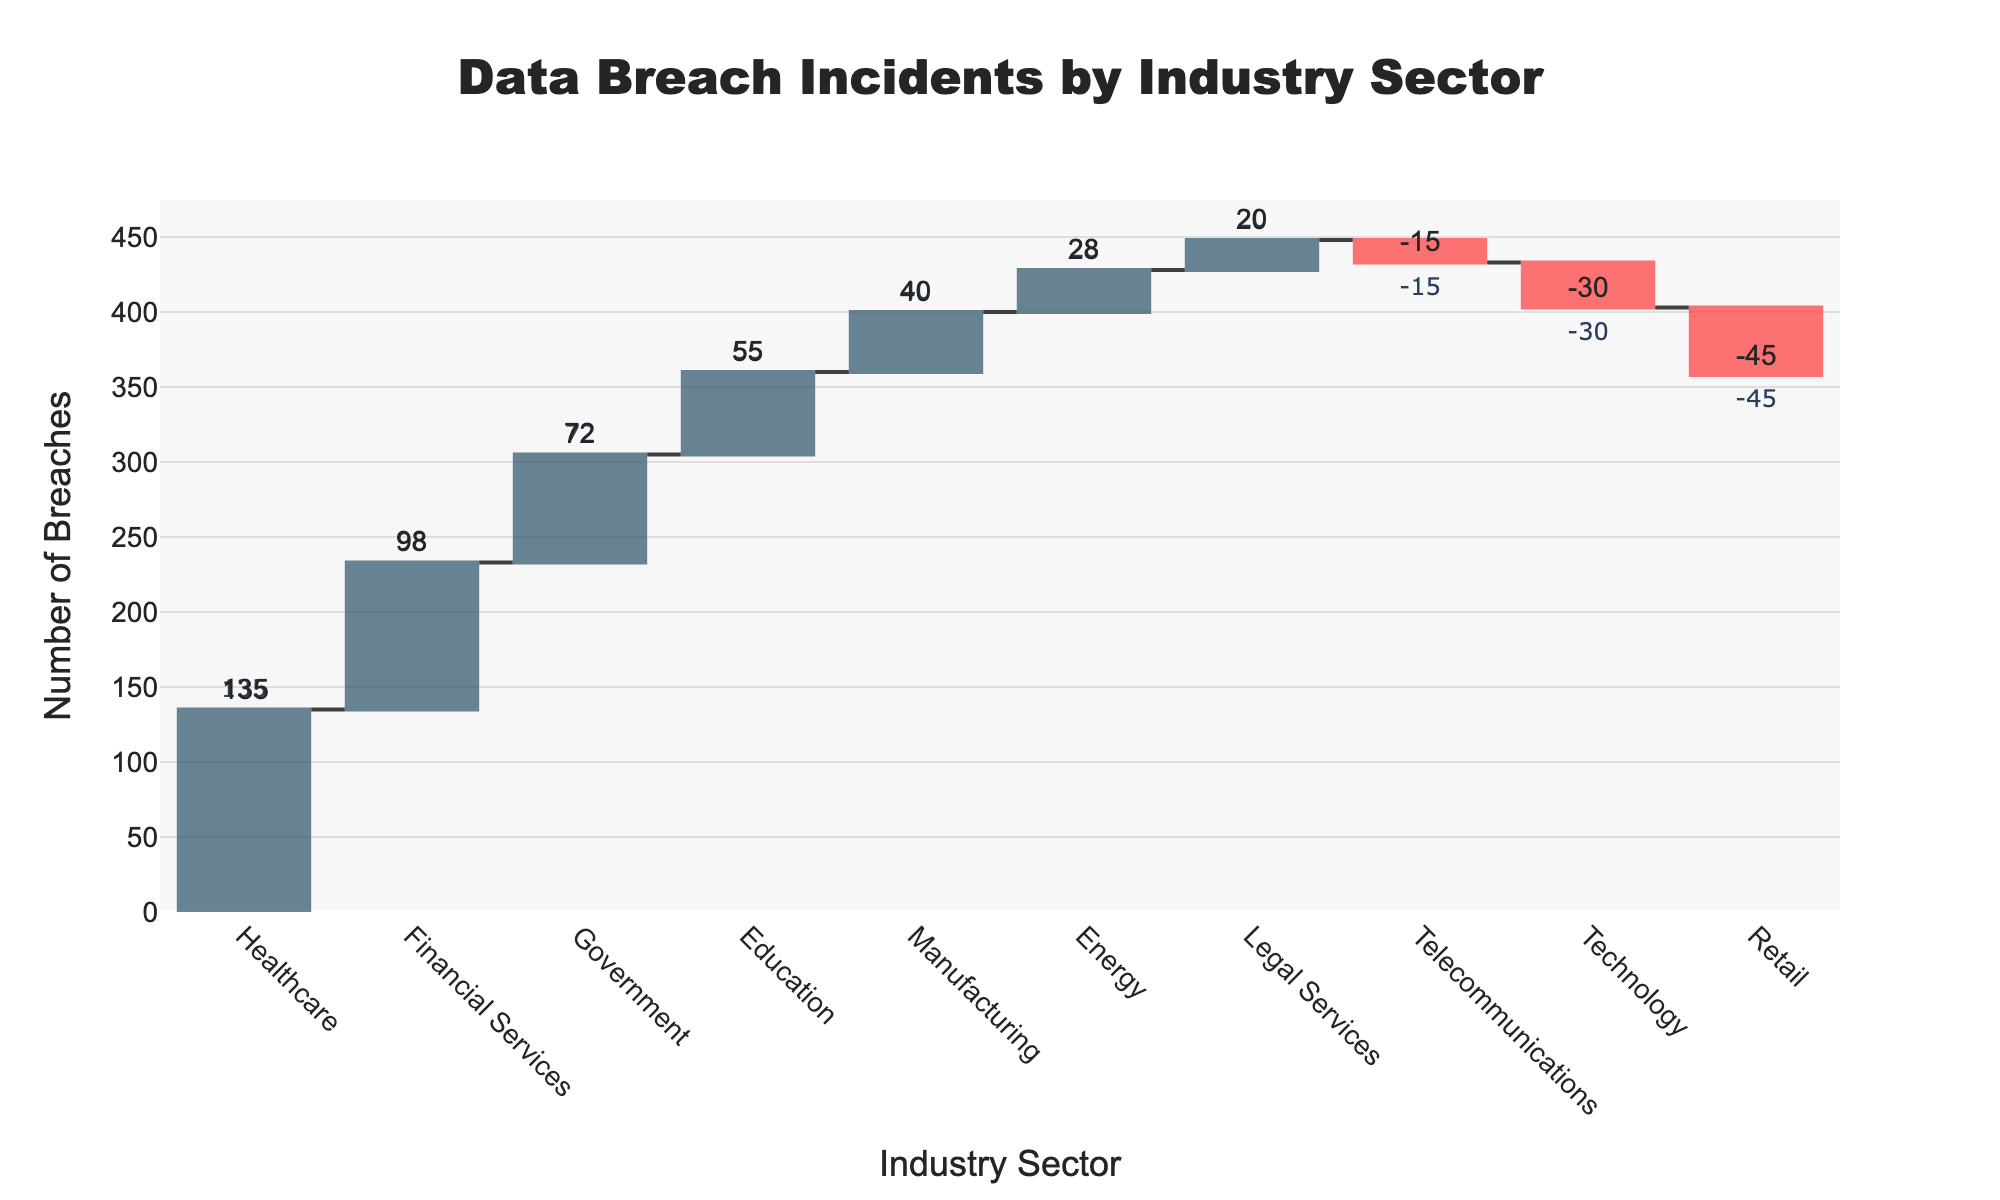What is the title of the plot? The title of the plot is displayed at the top of the figure and typically provides context to the graph. In this case, it reads "Data Breach Incidents by Industry Sector".
Answer: Data Breach Incidents by Industry Sector How many industry sectors experienced data breaches according to the chart? The x-axis of the plot lists the industry sectors. Counting these sectors gives the number of them. In this plot, there are 10 sectors displayed.
Answer: 10 Which industry sector had the highest number of breaches? Look for the tallest bar in the plot, where the bar is in positive direction. The Healthcare sector has the highest bar, indicating the most breaches.
Answer: Healthcare How many breaches did the Retail sector have? The Retail sector's bar is in the negative direction, and the text label outside the bar shows -45 breaches.
Answer: -45 What is the total number of breaches for the sectors with negative breaches combined? Identify the bars that are in the negative direction and sum their values: Retail (-45), Technology (-30), and Telecommunications (-15). Adding these gives -45 + (-30) + (-15) = -90.
Answer: -90 How does the number of breaches in Financial Services compare to that in Government? Compare the heights of the bars for Financial Services and Government. Financial Services has 98 breaches, while Government has 72 breaches. Therefore, Financial Services has more breaches than Government.
Answer: Financial Services has more What is the cumulative number of breaches after including the Education sector? To find the cumulative breaches until Education, sum the breaches from sectors before Education in the waterfall plot order: Healthcare (135) + Financial Services (98) + Government (72) + Education (55) = 360.
Answer: 360 Which industries have fewer than 30 breaches? Identify bars with values below 30. The Telecommunication bar has -15, indicating fewer than 30 breaches. The Energy sector has exactly 28 breaches, fitting the criteria as well.
Answer: Telecommunications and Energy Compare the breaches between Legal Services and Manufacturing sectors. Check the respective bars for breaches. Legal Services has 20 breaches, while Manufacturing has 40 breaches. Manufacturing has more breaches.
Answer: Manufacturing has more What is the overall trend depicted by the waterfall chart? Evaluate the sequences of bars in the chart. The initial sectors exhibit higher breaches, and the decrements seen in Retail, Technology, and Telecommunications are smaller relative to the upward trends in the other sectors. Overall, the trend indicates that positive breaches outweigh negative ones.
Answer: Positive breach trend 